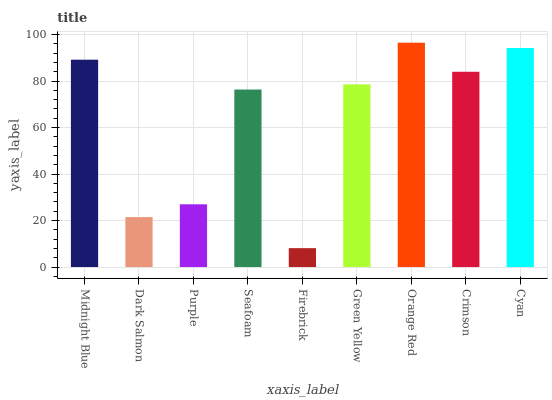Is Dark Salmon the minimum?
Answer yes or no. No. Is Dark Salmon the maximum?
Answer yes or no. No. Is Midnight Blue greater than Dark Salmon?
Answer yes or no. Yes. Is Dark Salmon less than Midnight Blue?
Answer yes or no. Yes. Is Dark Salmon greater than Midnight Blue?
Answer yes or no. No. Is Midnight Blue less than Dark Salmon?
Answer yes or no. No. Is Green Yellow the high median?
Answer yes or no. Yes. Is Green Yellow the low median?
Answer yes or no. Yes. Is Cyan the high median?
Answer yes or no. No. Is Crimson the low median?
Answer yes or no. No. 